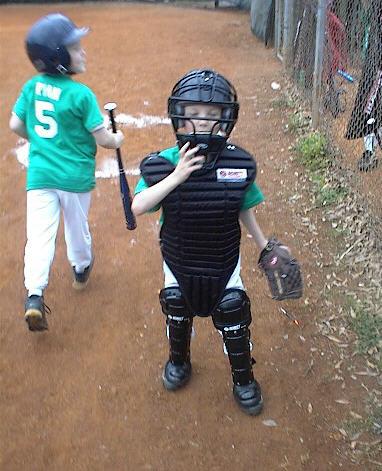What does the catcher wear on his knees?
Concise answer only. Knee pads. Are these professional players?
Give a very brief answer. No. Are both kids wearing green t-shirts?
Be succinct. Yes. 